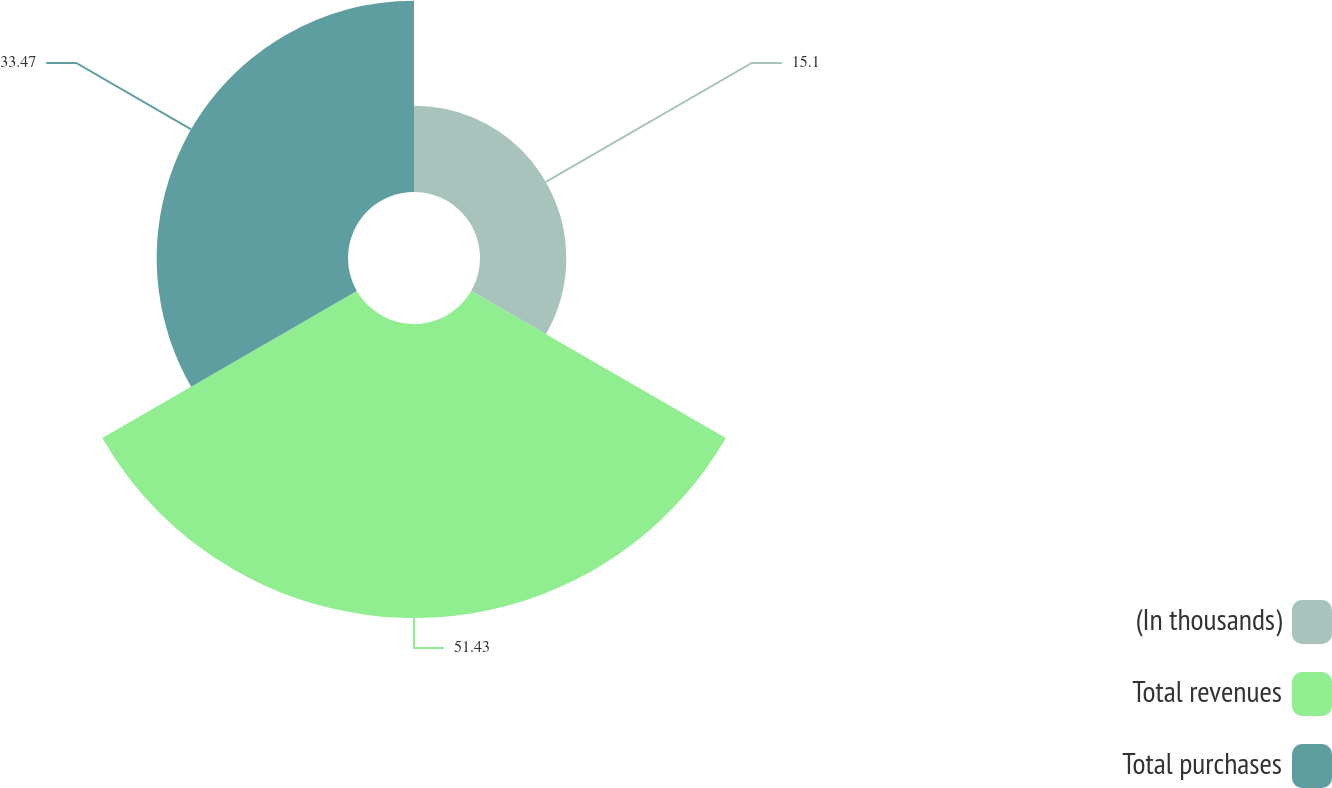Convert chart to OTSL. <chart><loc_0><loc_0><loc_500><loc_500><pie_chart><fcel>(In thousands)<fcel>Total revenues<fcel>Total purchases<nl><fcel>15.1%<fcel>51.43%<fcel>33.47%<nl></chart> 